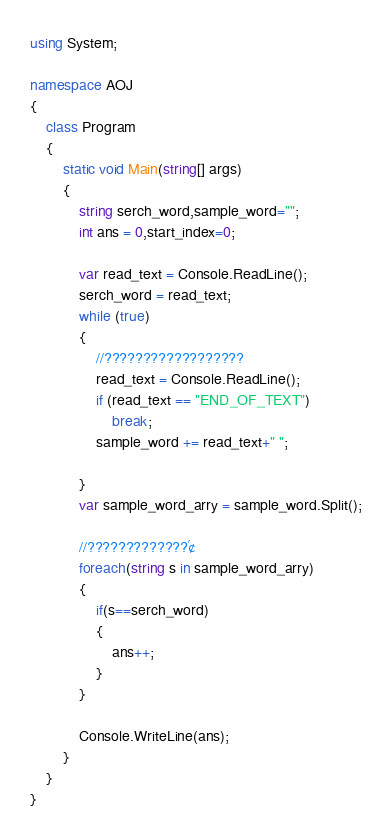Convert code to text. <code><loc_0><loc_0><loc_500><loc_500><_C#_>using System;

namespace AOJ
{
    class Program
    {
        static void Main(string[] args)
        {
            string serch_word,sample_word="";
            int ans = 0,start_index=0;

            var read_text = Console.ReadLine();
            serch_word = read_text;
            while (true)
            {
                //??????????????????
                read_text = Console.ReadLine();
                if (read_text == "END_OF_TEXT")
                    break;
                sample_word += read_text+" ";

            }
            var sample_word_arry = sample_word.Split();

            //?????????????´¢
            foreach(string s in sample_word_arry)
            {
                if(s==serch_word)
                {
                    ans++;
                }
            }

            Console.WriteLine(ans);
        }
    }
}</code> 